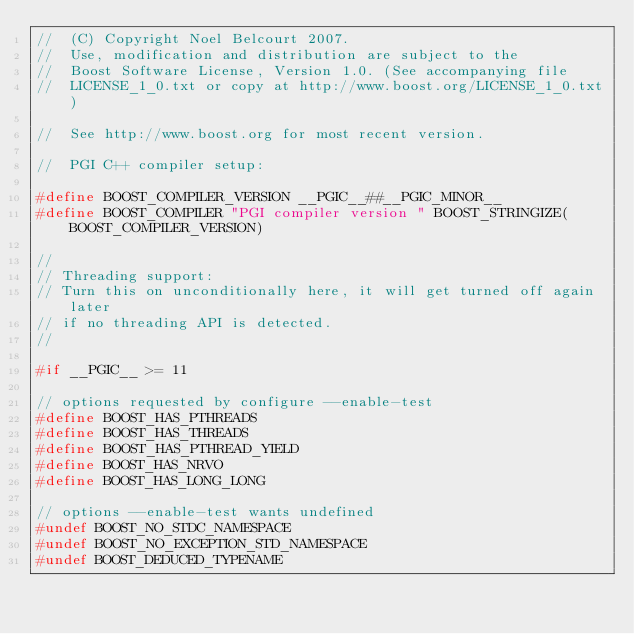<code> <loc_0><loc_0><loc_500><loc_500><_C++_>//  (C) Copyright Noel Belcourt 2007.
//  Use, modification and distribution are subject to the
//  Boost Software License, Version 1.0. (See accompanying file
//  LICENSE_1_0.txt or copy at http://www.boost.org/LICENSE_1_0.txt)

//  See http://www.boost.org for most recent version.

//  PGI C++ compiler setup:

#define BOOST_COMPILER_VERSION __PGIC__##__PGIC_MINOR__
#define BOOST_COMPILER "PGI compiler version " BOOST_STRINGIZE(BOOST_COMPILER_VERSION)

//
// Threading support:
// Turn this on unconditionally here, it will get turned off again later
// if no threading API is detected.
//

#if __PGIC__ >= 11

// options requested by configure --enable-test
#define BOOST_HAS_PTHREADS
#define BOOST_HAS_THREADS
#define BOOST_HAS_PTHREAD_YIELD
#define BOOST_HAS_NRVO
#define BOOST_HAS_LONG_LONG

// options --enable-test wants undefined
#undef BOOST_NO_STDC_NAMESPACE
#undef BOOST_NO_EXCEPTION_STD_NAMESPACE
#undef BOOST_DEDUCED_TYPENAME
</code> 